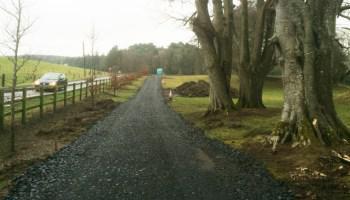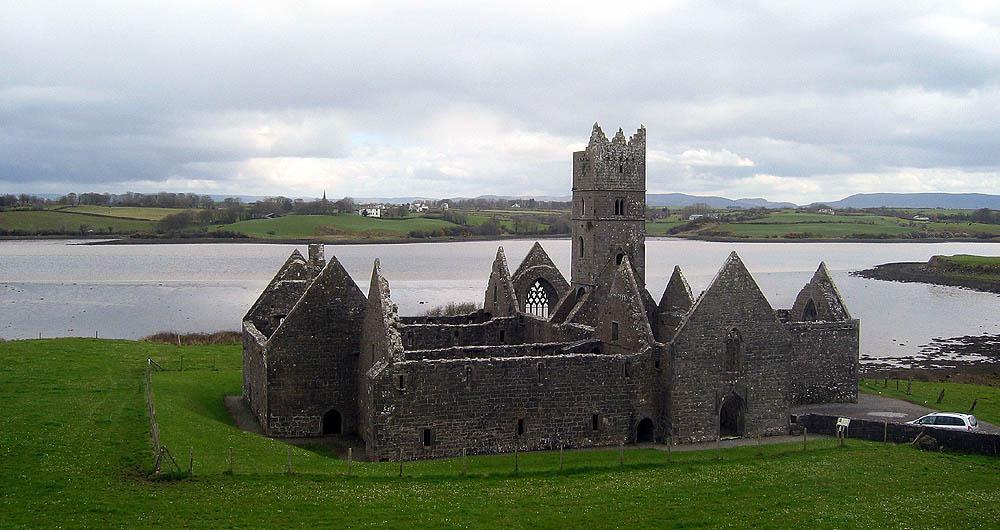The first image is the image on the left, the second image is the image on the right. Examine the images to the left and right. Is the description "There is a castle with a broken tower in the image on the left." accurate? Answer yes or no. No. 